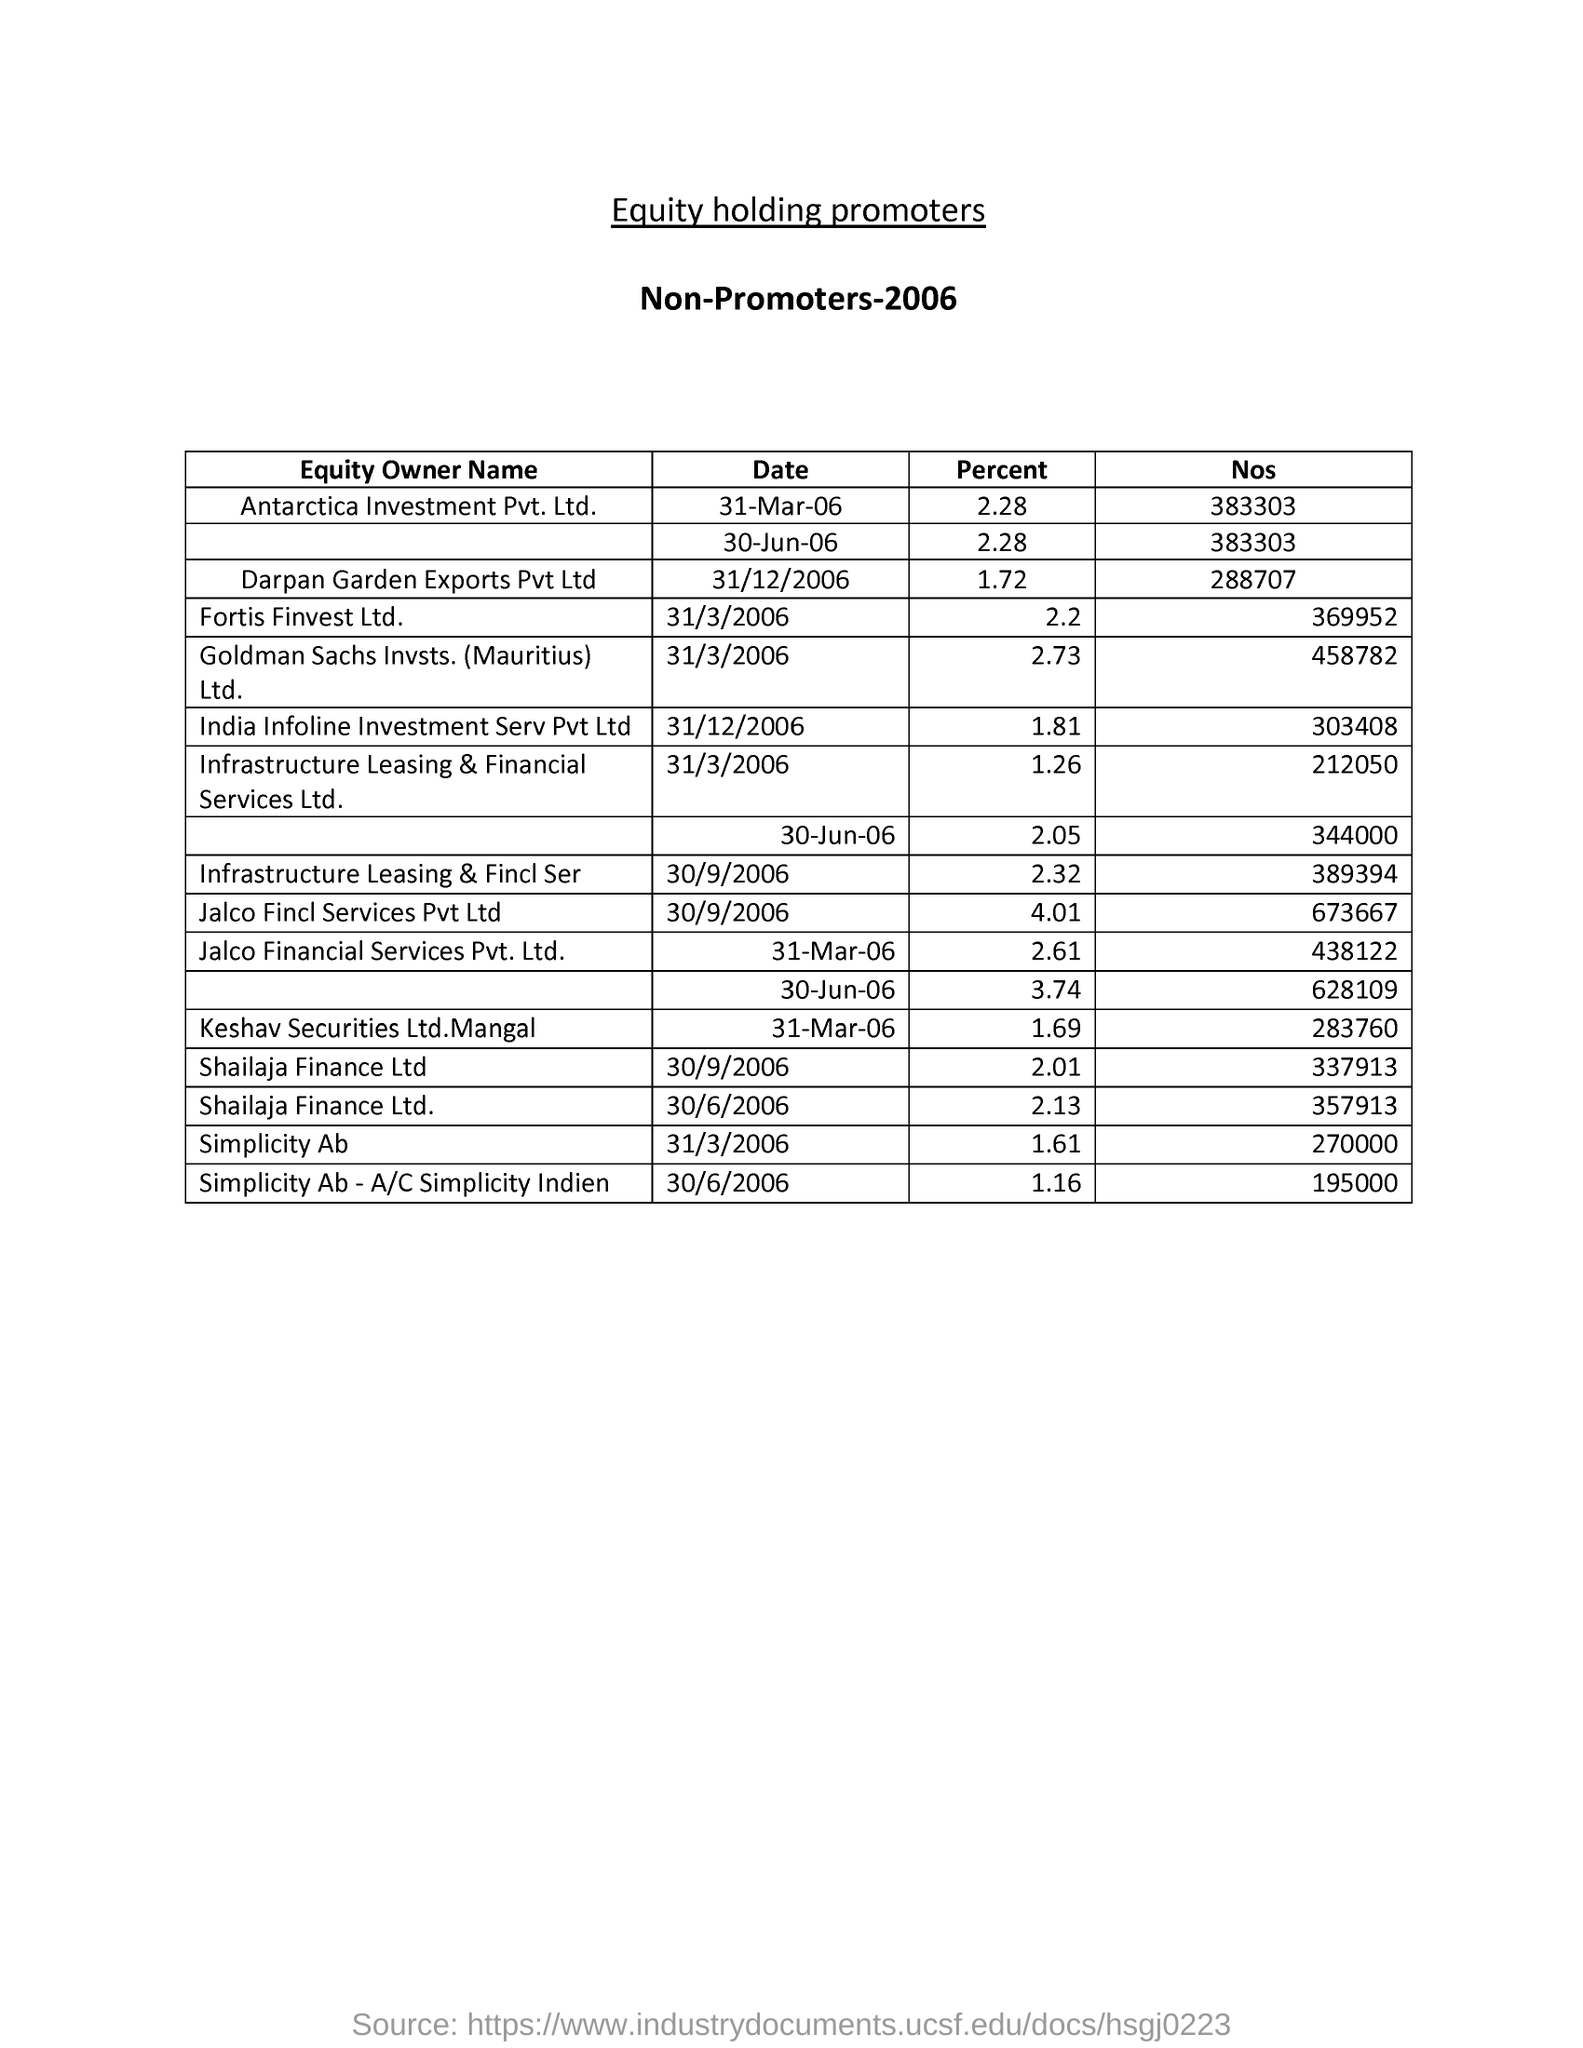What percent did Simplicity Ab have on 31/3/2006 ?
Your answer should be very brief. 1.61. 